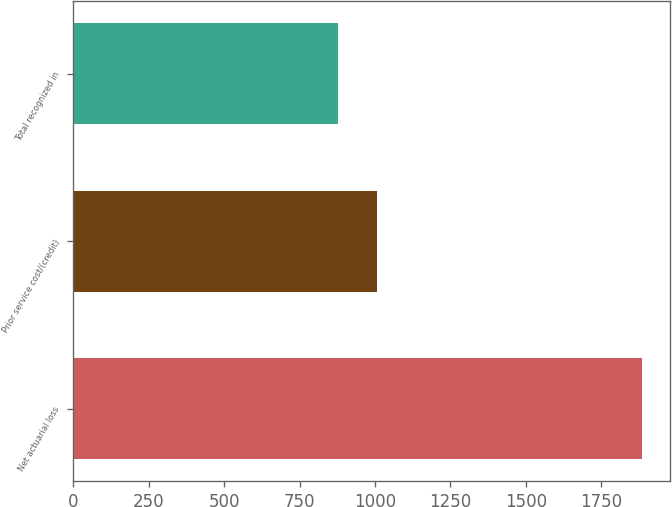<chart> <loc_0><loc_0><loc_500><loc_500><bar_chart><fcel>Net actuarial loss<fcel>Prior service cost/(credit)<fcel>Total recognized in<nl><fcel>1885<fcel>1008<fcel>877<nl></chart> 